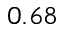Convert formula to latex. <formula><loc_0><loc_0><loc_500><loc_500>0 . 6 8</formula> 